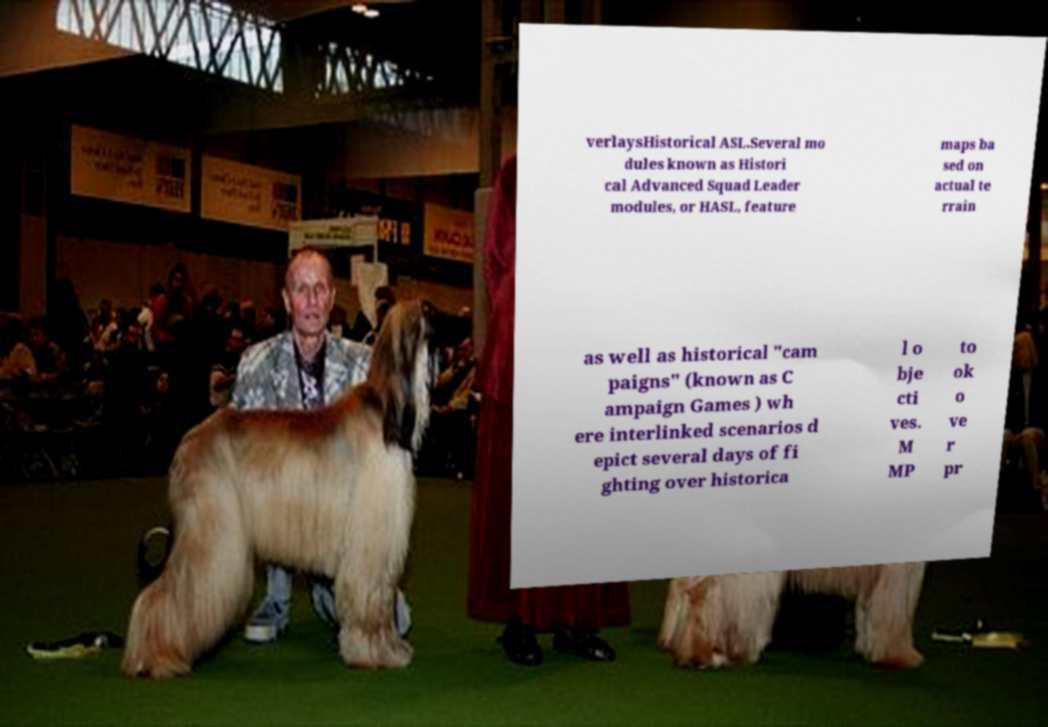What messages or text are displayed in this image? I need them in a readable, typed format. verlaysHistorical ASL.Several mo dules known as Histori cal Advanced Squad Leader modules, or HASL, feature maps ba sed on actual te rrain as well as historical "cam paigns" (known as C ampaign Games ) wh ere interlinked scenarios d epict several days of fi ghting over historica l o bje cti ves. M MP to ok o ve r pr 